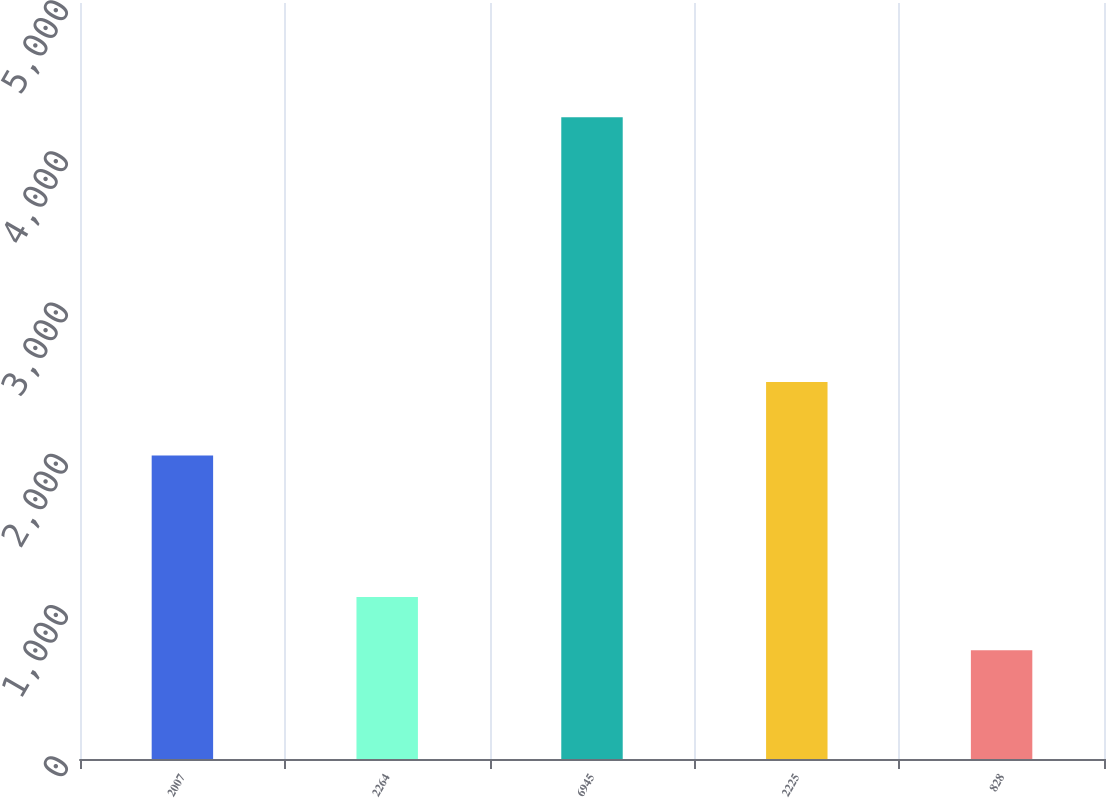Convert chart to OTSL. <chart><loc_0><loc_0><loc_500><loc_500><bar_chart><fcel>2007<fcel>2264<fcel>6945<fcel>2225<fcel>828<nl><fcel>2007<fcel>1071.6<fcel>4245<fcel>2494<fcel>719<nl></chart> 